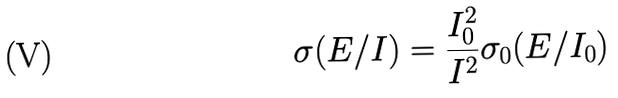<formula> <loc_0><loc_0><loc_500><loc_500>\sigma ( E / I ) = \frac { I _ { 0 } ^ { 2 } } { I ^ { 2 } } \sigma _ { 0 } ( E / I _ { 0 } )</formula> 